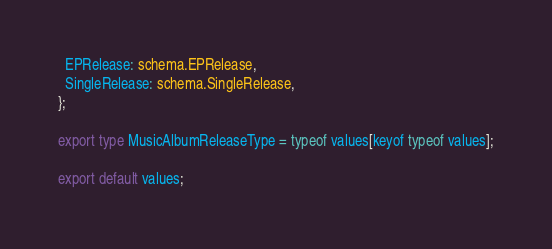<code> <loc_0><loc_0><loc_500><loc_500><_TypeScript_>  EPRelease: schema.EPRelease,
  SingleRelease: schema.SingleRelease,
};

export type MusicAlbumReleaseType = typeof values[keyof typeof values];

export default values;
</code> 